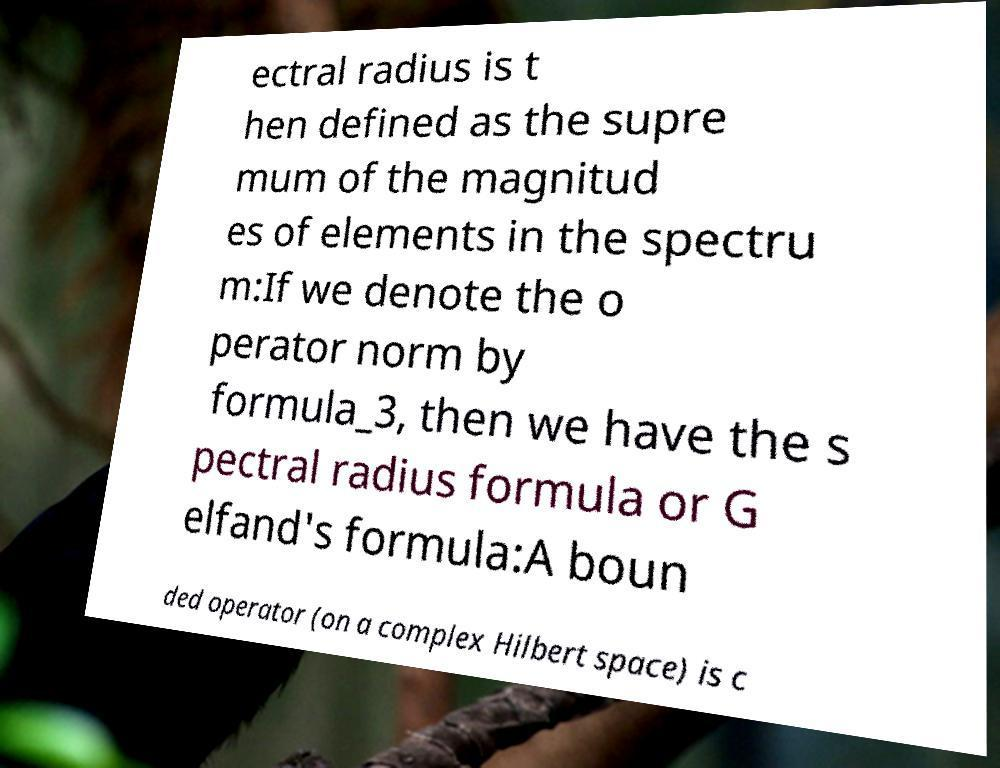Can you accurately transcribe the text from the provided image for me? ectral radius is t hen defined as the supre mum of the magnitud es of elements in the spectru m:If we denote the o perator norm by formula_3, then we have the s pectral radius formula or G elfand's formula:A boun ded operator (on a complex Hilbert space) is c 